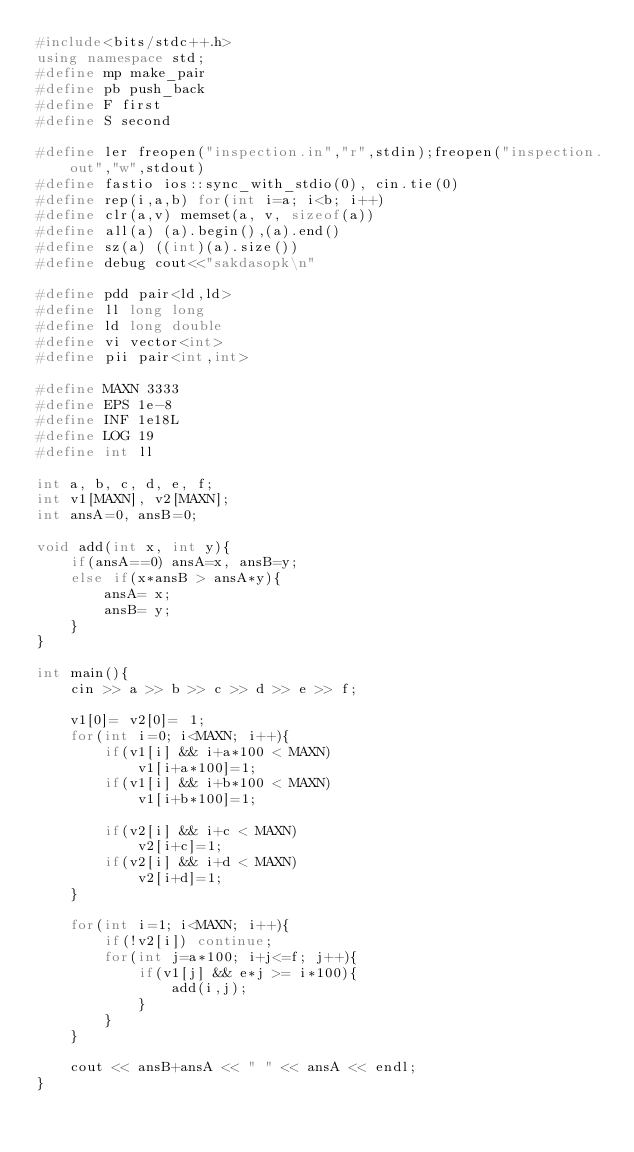<code> <loc_0><loc_0><loc_500><loc_500><_C++_>#include<bits/stdc++.h>
using namespace std;
#define mp make_pair
#define pb push_back
#define F first
#define S second
 
#define ler freopen("inspection.in","r",stdin);freopen("inspection.out","w",stdout)
#define fastio ios::sync_with_stdio(0), cin.tie(0)
#define rep(i,a,b) for(int i=a; i<b; i++)
#define clr(a,v) memset(a, v, sizeof(a))
#define all(a) (a).begin(),(a).end()
#define sz(a) ((int)(a).size())
#define debug cout<<"sakdasopk\n"
 
#define pdd pair<ld,ld> 
#define ll long long
#define ld long double
#define vi vector<int> 
#define pii pair<int,int>  
 
#define MAXN 3333
#define EPS 1e-8
#define INF 1e18L
#define LOG 19
#define int ll
	
int a, b, c, d, e, f;
int v1[MAXN], v2[MAXN];
int ansA=0, ansB=0;

void add(int x, int y){
	if(ansA==0) ansA=x, ansB=y;
	else if(x*ansB > ansA*y){
		ansA= x;
		ansB= y;
	}
}

int main(){
	cin >> a >> b >> c >> d >> e >> f;
	
	v1[0]= v2[0]= 1;
	for(int i=0; i<MAXN; i++){
		if(v1[i] && i+a*100 < MAXN)
			v1[i+a*100]=1;
		if(v1[i] && i+b*100 < MAXN)
			v1[i+b*100]=1;
			
		if(v2[i] && i+c < MAXN)
			v2[i+c]=1;
		if(v2[i] && i+d < MAXN)
			v2[i+d]=1;
	}

	for(int i=1; i<MAXN; i++){	
		if(!v2[i]) continue;
		for(int j=a*100; i+j<=f; j++){
			if(v1[j] && e*j >= i*100){
				add(i,j);
			}
		}
	}
	
	cout << ansB+ansA << " " << ansA << endl;
}

</code> 